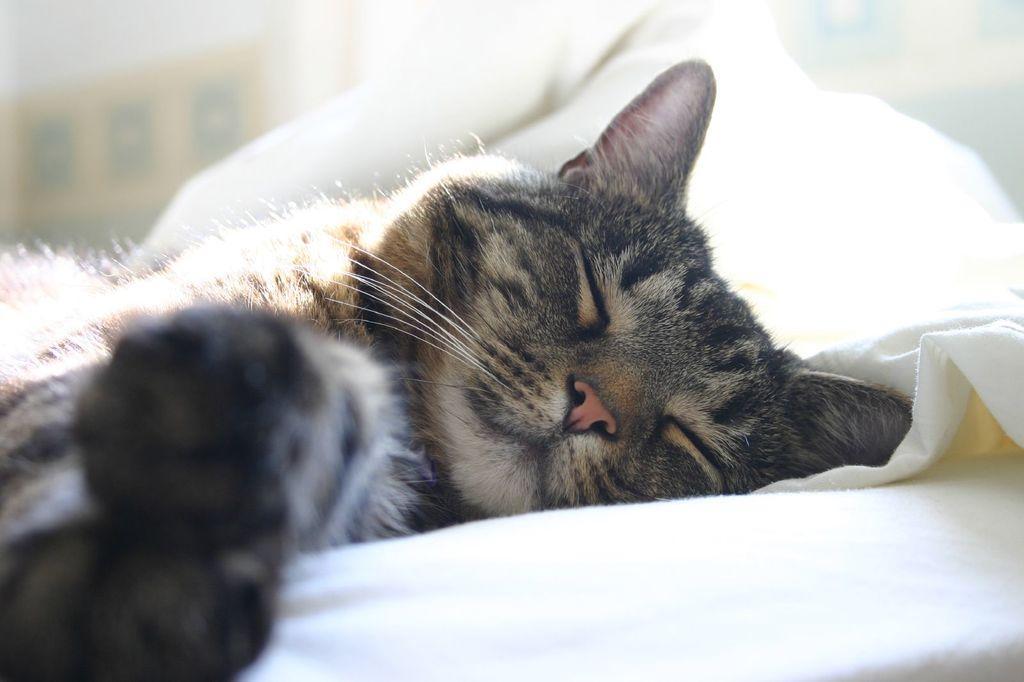Describe this image in one or two sentences. In this image we can see a cat lying on a cloth. 